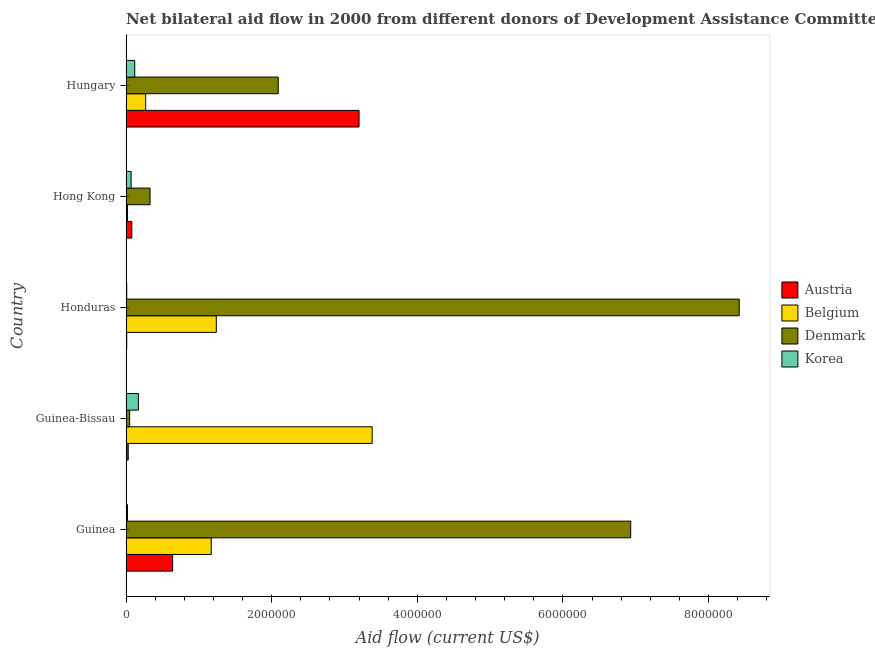How many different coloured bars are there?
Make the answer very short. 4. How many groups of bars are there?
Your answer should be compact. 5. How many bars are there on the 3rd tick from the top?
Give a very brief answer. 4. What is the label of the 5th group of bars from the top?
Your response must be concise. Guinea. In how many cases, is the number of bars for a given country not equal to the number of legend labels?
Offer a terse response. 0. What is the amount of aid given by austria in Hong Kong?
Make the answer very short. 8.00e+04. Across all countries, what is the maximum amount of aid given by belgium?
Give a very brief answer. 3.38e+06. Across all countries, what is the minimum amount of aid given by belgium?
Offer a terse response. 2.00e+04. In which country was the amount of aid given by austria maximum?
Ensure brevity in your answer.  Hungary. In which country was the amount of aid given by belgium minimum?
Provide a succinct answer. Hong Kong. What is the total amount of aid given by austria in the graph?
Offer a terse response. 3.96e+06. What is the difference between the amount of aid given by denmark in Guinea and that in Honduras?
Provide a short and direct response. -1.49e+06. What is the difference between the amount of aid given by belgium in Honduras and the amount of aid given by austria in Hong Kong?
Your answer should be compact. 1.16e+06. What is the average amount of aid given by korea per country?
Offer a terse response. 7.80e+04. What is the difference between the amount of aid given by belgium and amount of aid given by denmark in Hungary?
Ensure brevity in your answer.  -1.82e+06. In how many countries, is the amount of aid given by austria greater than 1600000 US$?
Ensure brevity in your answer.  1. What is the ratio of the amount of aid given by korea in Guinea to that in Hong Kong?
Offer a very short reply. 0.29. Is the difference between the amount of aid given by belgium in Guinea-Bissau and Hungary greater than the difference between the amount of aid given by austria in Guinea-Bissau and Hungary?
Keep it short and to the point. Yes. What is the difference between the highest and the second highest amount of aid given by austria?
Offer a very short reply. 2.56e+06. What is the difference between the highest and the lowest amount of aid given by korea?
Provide a succinct answer. 1.60e+05. In how many countries, is the amount of aid given by austria greater than the average amount of aid given by austria taken over all countries?
Make the answer very short. 1. Is it the case that in every country, the sum of the amount of aid given by austria and amount of aid given by belgium is greater than the sum of amount of aid given by denmark and amount of aid given by korea?
Keep it short and to the point. No. What does the 3rd bar from the top in Guinea represents?
Your response must be concise. Belgium. What does the 4th bar from the bottom in Hungary represents?
Your answer should be compact. Korea. Are all the bars in the graph horizontal?
Ensure brevity in your answer.  Yes. How many countries are there in the graph?
Provide a succinct answer. 5. What is the difference between two consecutive major ticks on the X-axis?
Give a very brief answer. 2.00e+06. Does the graph contain any zero values?
Your response must be concise. No. Where does the legend appear in the graph?
Give a very brief answer. Center right. What is the title of the graph?
Provide a short and direct response. Net bilateral aid flow in 2000 from different donors of Development Assistance Committee. What is the label or title of the Y-axis?
Give a very brief answer. Country. What is the Aid flow (current US$) of Austria in Guinea?
Make the answer very short. 6.40e+05. What is the Aid flow (current US$) in Belgium in Guinea?
Give a very brief answer. 1.17e+06. What is the Aid flow (current US$) of Denmark in Guinea?
Offer a terse response. 6.93e+06. What is the Aid flow (current US$) of Korea in Guinea?
Ensure brevity in your answer.  2.00e+04. What is the Aid flow (current US$) in Austria in Guinea-Bissau?
Offer a terse response. 3.00e+04. What is the Aid flow (current US$) in Belgium in Guinea-Bissau?
Keep it short and to the point. 3.38e+06. What is the Aid flow (current US$) in Denmark in Guinea-Bissau?
Give a very brief answer. 5.00e+04. What is the Aid flow (current US$) of Korea in Guinea-Bissau?
Offer a terse response. 1.70e+05. What is the Aid flow (current US$) in Belgium in Honduras?
Your answer should be very brief. 1.24e+06. What is the Aid flow (current US$) of Denmark in Honduras?
Your response must be concise. 8.42e+06. What is the Aid flow (current US$) of Korea in Honduras?
Make the answer very short. 10000. What is the Aid flow (current US$) of Austria in Hungary?
Your answer should be very brief. 3.20e+06. What is the Aid flow (current US$) of Denmark in Hungary?
Provide a short and direct response. 2.09e+06. What is the Aid flow (current US$) of Korea in Hungary?
Provide a succinct answer. 1.20e+05. Across all countries, what is the maximum Aid flow (current US$) in Austria?
Your answer should be compact. 3.20e+06. Across all countries, what is the maximum Aid flow (current US$) in Belgium?
Provide a succinct answer. 3.38e+06. Across all countries, what is the maximum Aid flow (current US$) of Denmark?
Make the answer very short. 8.42e+06. Across all countries, what is the maximum Aid flow (current US$) in Korea?
Keep it short and to the point. 1.70e+05. What is the total Aid flow (current US$) in Austria in the graph?
Keep it short and to the point. 3.96e+06. What is the total Aid flow (current US$) of Belgium in the graph?
Your response must be concise. 6.08e+06. What is the total Aid flow (current US$) in Denmark in the graph?
Offer a very short reply. 1.78e+07. What is the difference between the Aid flow (current US$) in Belgium in Guinea and that in Guinea-Bissau?
Make the answer very short. -2.21e+06. What is the difference between the Aid flow (current US$) in Denmark in Guinea and that in Guinea-Bissau?
Your answer should be compact. 6.88e+06. What is the difference between the Aid flow (current US$) in Austria in Guinea and that in Honduras?
Provide a short and direct response. 6.30e+05. What is the difference between the Aid flow (current US$) of Belgium in Guinea and that in Honduras?
Ensure brevity in your answer.  -7.00e+04. What is the difference between the Aid flow (current US$) of Denmark in Guinea and that in Honduras?
Keep it short and to the point. -1.49e+06. What is the difference between the Aid flow (current US$) in Korea in Guinea and that in Honduras?
Your answer should be compact. 10000. What is the difference between the Aid flow (current US$) of Austria in Guinea and that in Hong Kong?
Your response must be concise. 5.60e+05. What is the difference between the Aid flow (current US$) of Belgium in Guinea and that in Hong Kong?
Your answer should be compact. 1.15e+06. What is the difference between the Aid flow (current US$) of Denmark in Guinea and that in Hong Kong?
Your answer should be compact. 6.60e+06. What is the difference between the Aid flow (current US$) in Korea in Guinea and that in Hong Kong?
Your answer should be very brief. -5.00e+04. What is the difference between the Aid flow (current US$) of Austria in Guinea and that in Hungary?
Provide a short and direct response. -2.56e+06. What is the difference between the Aid flow (current US$) in Belgium in Guinea and that in Hungary?
Your answer should be very brief. 9.00e+05. What is the difference between the Aid flow (current US$) of Denmark in Guinea and that in Hungary?
Your answer should be compact. 4.84e+06. What is the difference between the Aid flow (current US$) in Belgium in Guinea-Bissau and that in Honduras?
Offer a very short reply. 2.14e+06. What is the difference between the Aid flow (current US$) in Denmark in Guinea-Bissau and that in Honduras?
Offer a terse response. -8.37e+06. What is the difference between the Aid flow (current US$) of Korea in Guinea-Bissau and that in Honduras?
Provide a short and direct response. 1.60e+05. What is the difference between the Aid flow (current US$) in Austria in Guinea-Bissau and that in Hong Kong?
Ensure brevity in your answer.  -5.00e+04. What is the difference between the Aid flow (current US$) in Belgium in Guinea-Bissau and that in Hong Kong?
Provide a succinct answer. 3.36e+06. What is the difference between the Aid flow (current US$) in Denmark in Guinea-Bissau and that in Hong Kong?
Keep it short and to the point. -2.80e+05. What is the difference between the Aid flow (current US$) in Austria in Guinea-Bissau and that in Hungary?
Provide a short and direct response. -3.17e+06. What is the difference between the Aid flow (current US$) of Belgium in Guinea-Bissau and that in Hungary?
Offer a terse response. 3.11e+06. What is the difference between the Aid flow (current US$) of Denmark in Guinea-Bissau and that in Hungary?
Your response must be concise. -2.04e+06. What is the difference between the Aid flow (current US$) of Austria in Honduras and that in Hong Kong?
Keep it short and to the point. -7.00e+04. What is the difference between the Aid flow (current US$) of Belgium in Honduras and that in Hong Kong?
Your answer should be compact. 1.22e+06. What is the difference between the Aid flow (current US$) in Denmark in Honduras and that in Hong Kong?
Keep it short and to the point. 8.09e+06. What is the difference between the Aid flow (current US$) in Austria in Honduras and that in Hungary?
Your response must be concise. -3.19e+06. What is the difference between the Aid flow (current US$) in Belgium in Honduras and that in Hungary?
Make the answer very short. 9.70e+05. What is the difference between the Aid flow (current US$) in Denmark in Honduras and that in Hungary?
Give a very brief answer. 6.33e+06. What is the difference between the Aid flow (current US$) of Austria in Hong Kong and that in Hungary?
Provide a short and direct response. -3.12e+06. What is the difference between the Aid flow (current US$) of Denmark in Hong Kong and that in Hungary?
Provide a succinct answer. -1.76e+06. What is the difference between the Aid flow (current US$) of Korea in Hong Kong and that in Hungary?
Ensure brevity in your answer.  -5.00e+04. What is the difference between the Aid flow (current US$) in Austria in Guinea and the Aid flow (current US$) in Belgium in Guinea-Bissau?
Make the answer very short. -2.74e+06. What is the difference between the Aid flow (current US$) in Austria in Guinea and the Aid flow (current US$) in Denmark in Guinea-Bissau?
Make the answer very short. 5.90e+05. What is the difference between the Aid flow (current US$) in Austria in Guinea and the Aid flow (current US$) in Korea in Guinea-Bissau?
Offer a terse response. 4.70e+05. What is the difference between the Aid flow (current US$) of Belgium in Guinea and the Aid flow (current US$) of Denmark in Guinea-Bissau?
Offer a terse response. 1.12e+06. What is the difference between the Aid flow (current US$) in Belgium in Guinea and the Aid flow (current US$) in Korea in Guinea-Bissau?
Offer a terse response. 1.00e+06. What is the difference between the Aid flow (current US$) of Denmark in Guinea and the Aid flow (current US$) of Korea in Guinea-Bissau?
Your response must be concise. 6.76e+06. What is the difference between the Aid flow (current US$) in Austria in Guinea and the Aid flow (current US$) in Belgium in Honduras?
Offer a very short reply. -6.00e+05. What is the difference between the Aid flow (current US$) of Austria in Guinea and the Aid flow (current US$) of Denmark in Honduras?
Your answer should be compact. -7.78e+06. What is the difference between the Aid flow (current US$) of Austria in Guinea and the Aid flow (current US$) of Korea in Honduras?
Your answer should be very brief. 6.30e+05. What is the difference between the Aid flow (current US$) of Belgium in Guinea and the Aid flow (current US$) of Denmark in Honduras?
Ensure brevity in your answer.  -7.25e+06. What is the difference between the Aid flow (current US$) of Belgium in Guinea and the Aid flow (current US$) of Korea in Honduras?
Keep it short and to the point. 1.16e+06. What is the difference between the Aid flow (current US$) of Denmark in Guinea and the Aid flow (current US$) of Korea in Honduras?
Offer a very short reply. 6.92e+06. What is the difference between the Aid flow (current US$) in Austria in Guinea and the Aid flow (current US$) in Belgium in Hong Kong?
Offer a very short reply. 6.20e+05. What is the difference between the Aid flow (current US$) of Austria in Guinea and the Aid flow (current US$) of Korea in Hong Kong?
Your answer should be compact. 5.70e+05. What is the difference between the Aid flow (current US$) in Belgium in Guinea and the Aid flow (current US$) in Denmark in Hong Kong?
Keep it short and to the point. 8.40e+05. What is the difference between the Aid flow (current US$) in Belgium in Guinea and the Aid flow (current US$) in Korea in Hong Kong?
Offer a terse response. 1.10e+06. What is the difference between the Aid flow (current US$) in Denmark in Guinea and the Aid flow (current US$) in Korea in Hong Kong?
Ensure brevity in your answer.  6.86e+06. What is the difference between the Aid flow (current US$) of Austria in Guinea and the Aid flow (current US$) of Belgium in Hungary?
Ensure brevity in your answer.  3.70e+05. What is the difference between the Aid flow (current US$) in Austria in Guinea and the Aid flow (current US$) in Denmark in Hungary?
Offer a terse response. -1.45e+06. What is the difference between the Aid flow (current US$) in Austria in Guinea and the Aid flow (current US$) in Korea in Hungary?
Keep it short and to the point. 5.20e+05. What is the difference between the Aid flow (current US$) of Belgium in Guinea and the Aid flow (current US$) of Denmark in Hungary?
Offer a very short reply. -9.20e+05. What is the difference between the Aid flow (current US$) in Belgium in Guinea and the Aid flow (current US$) in Korea in Hungary?
Your response must be concise. 1.05e+06. What is the difference between the Aid flow (current US$) in Denmark in Guinea and the Aid flow (current US$) in Korea in Hungary?
Keep it short and to the point. 6.81e+06. What is the difference between the Aid flow (current US$) of Austria in Guinea-Bissau and the Aid flow (current US$) of Belgium in Honduras?
Your answer should be compact. -1.21e+06. What is the difference between the Aid flow (current US$) of Austria in Guinea-Bissau and the Aid flow (current US$) of Denmark in Honduras?
Ensure brevity in your answer.  -8.39e+06. What is the difference between the Aid flow (current US$) of Austria in Guinea-Bissau and the Aid flow (current US$) of Korea in Honduras?
Offer a terse response. 2.00e+04. What is the difference between the Aid flow (current US$) of Belgium in Guinea-Bissau and the Aid flow (current US$) of Denmark in Honduras?
Ensure brevity in your answer.  -5.04e+06. What is the difference between the Aid flow (current US$) of Belgium in Guinea-Bissau and the Aid flow (current US$) of Korea in Honduras?
Ensure brevity in your answer.  3.37e+06. What is the difference between the Aid flow (current US$) in Denmark in Guinea-Bissau and the Aid flow (current US$) in Korea in Honduras?
Your response must be concise. 4.00e+04. What is the difference between the Aid flow (current US$) of Austria in Guinea-Bissau and the Aid flow (current US$) of Belgium in Hong Kong?
Provide a succinct answer. 10000. What is the difference between the Aid flow (current US$) in Austria in Guinea-Bissau and the Aid flow (current US$) in Denmark in Hong Kong?
Your response must be concise. -3.00e+05. What is the difference between the Aid flow (current US$) in Belgium in Guinea-Bissau and the Aid flow (current US$) in Denmark in Hong Kong?
Offer a very short reply. 3.05e+06. What is the difference between the Aid flow (current US$) in Belgium in Guinea-Bissau and the Aid flow (current US$) in Korea in Hong Kong?
Ensure brevity in your answer.  3.31e+06. What is the difference between the Aid flow (current US$) of Denmark in Guinea-Bissau and the Aid flow (current US$) of Korea in Hong Kong?
Give a very brief answer. -2.00e+04. What is the difference between the Aid flow (current US$) in Austria in Guinea-Bissau and the Aid flow (current US$) in Belgium in Hungary?
Provide a short and direct response. -2.40e+05. What is the difference between the Aid flow (current US$) of Austria in Guinea-Bissau and the Aid flow (current US$) of Denmark in Hungary?
Make the answer very short. -2.06e+06. What is the difference between the Aid flow (current US$) of Belgium in Guinea-Bissau and the Aid flow (current US$) of Denmark in Hungary?
Offer a terse response. 1.29e+06. What is the difference between the Aid flow (current US$) of Belgium in Guinea-Bissau and the Aid flow (current US$) of Korea in Hungary?
Offer a terse response. 3.26e+06. What is the difference between the Aid flow (current US$) of Denmark in Guinea-Bissau and the Aid flow (current US$) of Korea in Hungary?
Provide a short and direct response. -7.00e+04. What is the difference between the Aid flow (current US$) of Austria in Honduras and the Aid flow (current US$) of Denmark in Hong Kong?
Offer a very short reply. -3.20e+05. What is the difference between the Aid flow (current US$) of Belgium in Honduras and the Aid flow (current US$) of Denmark in Hong Kong?
Provide a succinct answer. 9.10e+05. What is the difference between the Aid flow (current US$) of Belgium in Honduras and the Aid flow (current US$) of Korea in Hong Kong?
Offer a very short reply. 1.17e+06. What is the difference between the Aid flow (current US$) in Denmark in Honduras and the Aid flow (current US$) in Korea in Hong Kong?
Give a very brief answer. 8.35e+06. What is the difference between the Aid flow (current US$) of Austria in Honduras and the Aid flow (current US$) of Belgium in Hungary?
Provide a short and direct response. -2.60e+05. What is the difference between the Aid flow (current US$) in Austria in Honduras and the Aid flow (current US$) in Denmark in Hungary?
Your response must be concise. -2.08e+06. What is the difference between the Aid flow (current US$) in Austria in Honduras and the Aid flow (current US$) in Korea in Hungary?
Offer a terse response. -1.10e+05. What is the difference between the Aid flow (current US$) in Belgium in Honduras and the Aid flow (current US$) in Denmark in Hungary?
Give a very brief answer. -8.50e+05. What is the difference between the Aid flow (current US$) in Belgium in Honduras and the Aid flow (current US$) in Korea in Hungary?
Provide a succinct answer. 1.12e+06. What is the difference between the Aid flow (current US$) of Denmark in Honduras and the Aid flow (current US$) of Korea in Hungary?
Provide a short and direct response. 8.30e+06. What is the difference between the Aid flow (current US$) of Austria in Hong Kong and the Aid flow (current US$) of Denmark in Hungary?
Offer a terse response. -2.01e+06. What is the difference between the Aid flow (current US$) in Belgium in Hong Kong and the Aid flow (current US$) in Denmark in Hungary?
Keep it short and to the point. -2.07e+06. What is the difference between the Aid flow (current US$) of Denmark in Hong Kong and the Aid flow (current US$) of Korea in Hungary?
Your response must be concise. 2.10e+05. What is the average Aid flow (current US$) of Austria per country?
Ensure brevity in your answer.  7.92e+05. What is the average Aid flow (current US$) in Belgium per country?
Ensure brevity in your answer.  1.22e+06. What is the average Aid flow (current US$) in Denmark per country?
Make the answer very short. 3.56e+06. What is the average Aid flow (current US$) of Korea per country?
Your answer should be compact. 7.80e+04. What is the difference between the Aid flow (current US$) in Austria and Aid flow (current US$) in Belgium in Guinea?
Ensure brevity in your answer.  -5.30e+05. What is the difference between the Aid flow (current US$) of Austria and Aid flow (current US$) of Denmark in Guinea?
Provide a succinct answer. -6.29e+06. What is the difference between the Aid flow (current US$) of Austria and Aid flow (current US$) of Korea in Guinea?
Offer a very short reply. 6.20e+05. What is the difference between the Aid flow (current US$) of Belgium and Aid flow (current US$) of Denmark in Guinea?
Provide a succinct answer. -5.76e+06. What is the difference between the Aid flow (current US$) in Belgium and Aid flow (current US$) in Korea in Guinea?
Provide a short and direct response. 1.15e+06. What is the difference between the Aid flow (current US$) of Denmark and Aid flow (current US$) of Korea in Guinea?
Keep it short and to the point. 6.91e+06. What is the difference between the Aid flow (current US$) of Austria and Aid flow (current US$) of Belgium in Guinea-Bissau?
Keep it short and to the point. -3.35e+06. What is the difference between the Aid flow (current US$) of Austria and Aid flow (current US$) of Denmark in Guinea-Bissau?
Offer a very short reply. -2.00e+04. What is the difference between the Aid flow (current US$) of Belgium and Aid flow (current US$) of Denmark in Guinea-Bissau?
Ensure brevity in your answer.  3.33e+06. What is the difference between the Aid flow (current US$) in Belgium and Aid flow (current US$) in Korea in Guinea-Bissau?
Offer a terse response. 3.21e+06. What is the difference between the Aid flow (current US$) in Denmark and Aid flow (current US$) in Korea in Guinea-Bissau?
Make the answer very short. -1.20e+05. What is the difference between the Aid flow (current US$) of Austria and Aid flow (current US$) of Belgium in Honduras?
Make the answer very short. -1.23e+06. What is the difference between the Aid flow (current US$) in Austria and Aid flow (current US$) in Denmark in Honduras?
Your answer should be compact. -8.41e+06. What is the difference between the Aid flow (current US$) of Austria and Aid flow (current US$) of Korea in Honduras?
Make the answer very short. 0. What is the difference between the Aid flow (current US$) in Belgium and Aid flow (current US$) in Denmark in Honduras?
Your response must be concise. -7.18e+06. What is the difference between the Aid flow (current US$) in Belgium and Aid flow (current US$) in Korea in Honduras?
Offer a very short reply. 1.23e+06. What is the difference between the Aid flow (current US$) in Denmark and Aid flow (current US$) in Korea in Honduras?
Your answer should be compact. 8.41e+06. What is the difference between the Aid flow (current US$) of Austria and Aid flow (current US$) of Denmark in Hong Kong?
Provide a succinct answer. -2.50e+05. What is the difference between the Aid flow (current US$) of Austria and Aid flow (current US$) of Korea in Hong Kong?
Make the answer very short. 10000. What is the difference between the Aid flow (current US$) in Belgium and Aid flow (current US$) in Denmark in Hong Kong?
Your answer should be very brief. -3.10e+05. What is the difference between the Aid flow (current US$) of Belgium and Aid flow (current US$) of Korea in Hong Kong?
Provide a short and direct response. -5.00e+04. What is the difference between the Aid flow (current US$) in Austria and Aid flow (current US$) in Belgium in Hungary?
Provide a short and direct response. 2.93e+06. What is the difference between the Aid flow (current US$) of Austria and Aid flow (current US$) of Denmark in Hungary?
Provide a succinct answer. 1.11e+06. What is the difference between the Aid flow (current US$) of Austria and Aid flow (current US$) of Korea in Hungary?
Provide a succinct answer. 3.08e+06. What is the difference between the Aid flow (current US$) in Belgium and Aid flow (current US$) in Denmark in Hungary?
Your response must be concise. -1.82e+06. What is the difference between the Aid flow (current US$) in Denmark and Aid flow (current US$) in Korea in Hungary?
Provide a succinct answer. 1.97e+06. What is the ratio of the Aid flow (current US$) of Austria in Guinea to that in Guinea-Bissau?
Ensure brevity in your answer.  21.33. What is the ratio of the Aid flow (current US$) of Belgium in Guinea to that in Guinea-Bissau?
Ensure brevity in your answer.  0.35. What is the ratio of the Aid flow (current US$) of Denmark in Guinea to that in Guinea-Bissau?
Make the answer very short. 138.6. What is the ratio of the Aid flow (current US$) of Korea in Guinea to that in Guinea-Bissau?
Your answer should be compact. 0.12. What is the ratio of the Aid flow (current US$) in Austria in Guinea to that in Honduras?
Ensure brevity in your answer.  64. What is the ratio of the Aid flow (current US$) of Belgium in Guinea to that in Honduras?
Offer a very short reply. 0.94. What is the ratio of the Aid flow (current US$) in Denmark in Guinea to that in Honduras?
Provide a short and direct response. 0.82. What is the ratio of the Aid flow (current US$) in Austria in Guinea to that in Hong Kong?
Ensure brevity in your answer.  8. What is the ratio of the Aid flow (current US$) of Belgium in Guinea to that in Hong Kong?
Offer a terse response. 58.5. What is the ratio of the Aid flow (current US$) of Korea in Guinea to that in Hong Kong?
Ensure brevity in your answer.  0.29. What is the ratio of the Aid flow (current US$) of Belgium in Guinea to that in Hungary?
Provide a short and direct response. 4.33. What is the ratio of the Aid flow (current US$) of Denmark in Guinea to that in Hungary?
Make the answer very short. 3.32. What is the ratio of the Aid flow (current US$) in Korea in Guinea to that in Hungary?
Offer a very short reply. 0.17. What is the ratio of the Aid flow (current US$) in Austria in Guinea-Bissau to that in Honduras?
Give a very brief answer. 3. What is the ratio of the Aid flow (current US$) in Belgium in Guinea-Bissau to that in Honduras?
Offer a terse response. 2.73. What is the ratio of the Aid flow (current US$) in Denmark in Guinea-Bissau to that in Honduras?
Make the answer very short. 0.01. What is the ratio of the Aid flow (current US$) in Korea in Guinea-Bissau to that in Honduras?
Make the answer very short. 17. What is the ratio of the Aid flow (current US$) in Austria in Guinea-Bissau to that in Hong Kong?
Your answer should be very brief. 0.38. What is the ratio of the Aid flow (current US$) in Belgium in Guinea-Bissau to that in Hong Kong?
Your response must be concise. 169. What is the ratio of the Aid flow (current US$) in Denmark in Guinea-Bissau to that in Hong Kong?
Your answer should be very brief. 0.15. What is the ratio of the Aid flow (current US$) in Korea in Guinea-Bissau to that in Hong Kong?
Your response must be concise. 2.43. What is the ratio of the Aid flow (current US$) of Austria in Guinea-Bissau to that in Hungary?
Make the answer very short. 0.01. What is the ratio of the Aid flow (current US$) in Belgium in Guinea-Bissau to that in Hungary?
Your answer should be very brief. 12.52. What is the ratio of the Aid flow (current US$) of Denmark in Guinea-Bissau to that in Hungary?
Offer a terse response. 0.02. What is the ratio of the Aid flow (current US$) in Korea in Guinea-Bissau to that in Hungary?
Your answer should be very brief. 1.42. What is the ratio of the Aid flow (current US$) in Austria in Honduras to that in Hong Kong?
Offer a terse response. 0.12. What is the ratio of the Aid flow (current US$) in Belgium in Honduras to that in Hong Kong?
Your response must be concise. 62. What is the ratio of the Aid flow (current US$) in Denmark in Honduras to that in Hong Kong?
Provide a short and direct response. 25.52. What is the ratio of the Aid flow (current US$) in Korea in Honduras to that in Hong Kong?
Give a very brief answer. 0.14. What is the ratio of the Aid flow (current US$) in Austria in Honduras to that in Hungary?
Your answer should be compact. 0. What is the ratio of the Aid flow (current US$) of Belgium in Honduras to that in Hungary?
Ensure brevity in your answer.  4.59. What is the ratio of the Aid flow (current US$) in Denmark in Honduras to that in Hungary?
Provide a short and direct response. 4.03. What is the ratio of the Aid flow (current US$) of Korea in Honduras to that in Hungary?
Your answer should be compact. 0.08. What is the ratio of the Aid flow (current US$) of Austria in Hong Kong to that in Hungary?
Your answer should be very brief. 0.03. What is the ratio of the Aid flow (current US$) of Belgium in Hong Kong to that in Hungary?
Keep it short and to the point. 0.07. What is the ratio of the Aid flow (current US$) of Denmark in Hong Kong to that in Hungary?
Offer a terse response. 0.16. What is the ratio of the Aid flow (current US$) of Korea in Hong Kong to that in Hungary?
Provide a short and direct response. 0.58. What is the difference between the highest and the second highest Aid flow (current US$) of Austria?
Your answer should be very brief. 2.56e+06. What is the difference between the highest and the second highest Aid flow (current US$) of Belgium?
Make the answer very short. 2.14e+06. What is the difference between the highest and the second highest Aid flow (current US$) of Denmark?
Give a very brief answer. 1.49e+06. What is the difference between the highest and the second highest Aid flow (current US$) in Korea?
Your answer should be compact. 5.00e+04. What is the difference between the highest and the lowest Aid flow (current US$) of Austria?
Your answer should be very brief. 3.19e+06. What is the difference between the highest and the lowest Aid flow (current US$) in Belgium?
Ensure brevity in your answer.  3.36e+06. What is the difference between the highest and the lowest Aid flow (current US$) of Denmark?
Make the answer very short. 8.37e+06. 